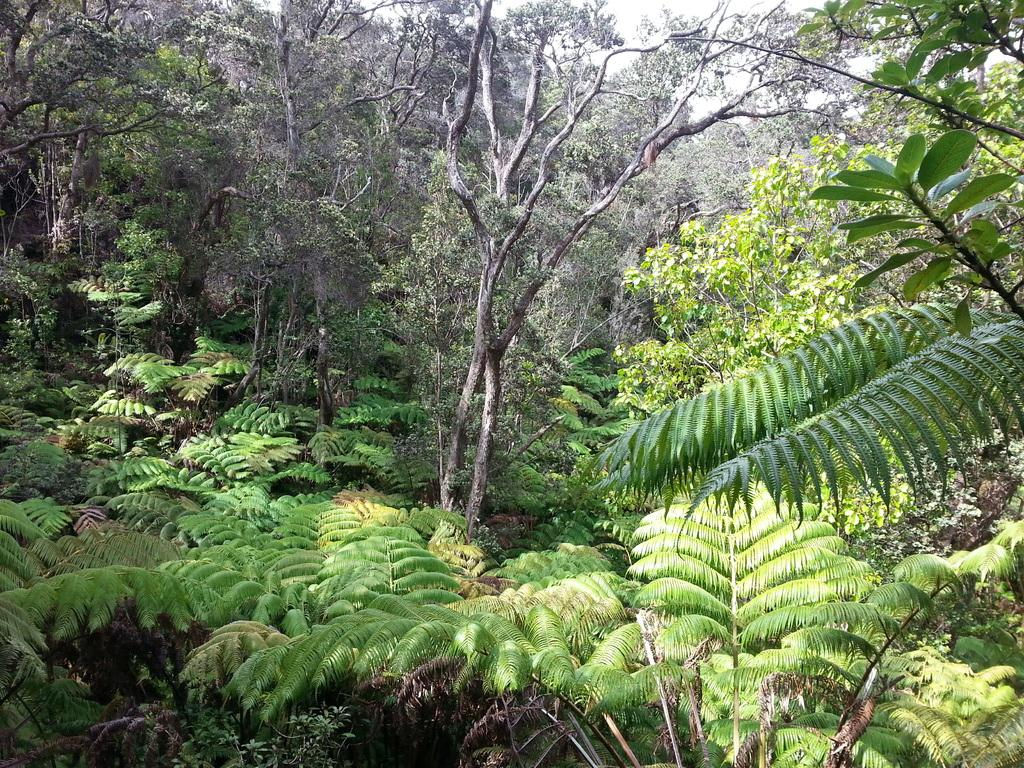What type of vegetation can be seen in the image? There are plants and trees in the image. What is visible at the top of the image? The sky is visible at the top of the image. What type of lumber is being used to build the scaffolding in the image? There is no scaffolding or lumber present in the image; it features plants, trees, and the sky. How many trips were taken to transport the plants and trees in the image? There is no information about trips or transportation in the image, as it only shows plants, trees, and the sky. 